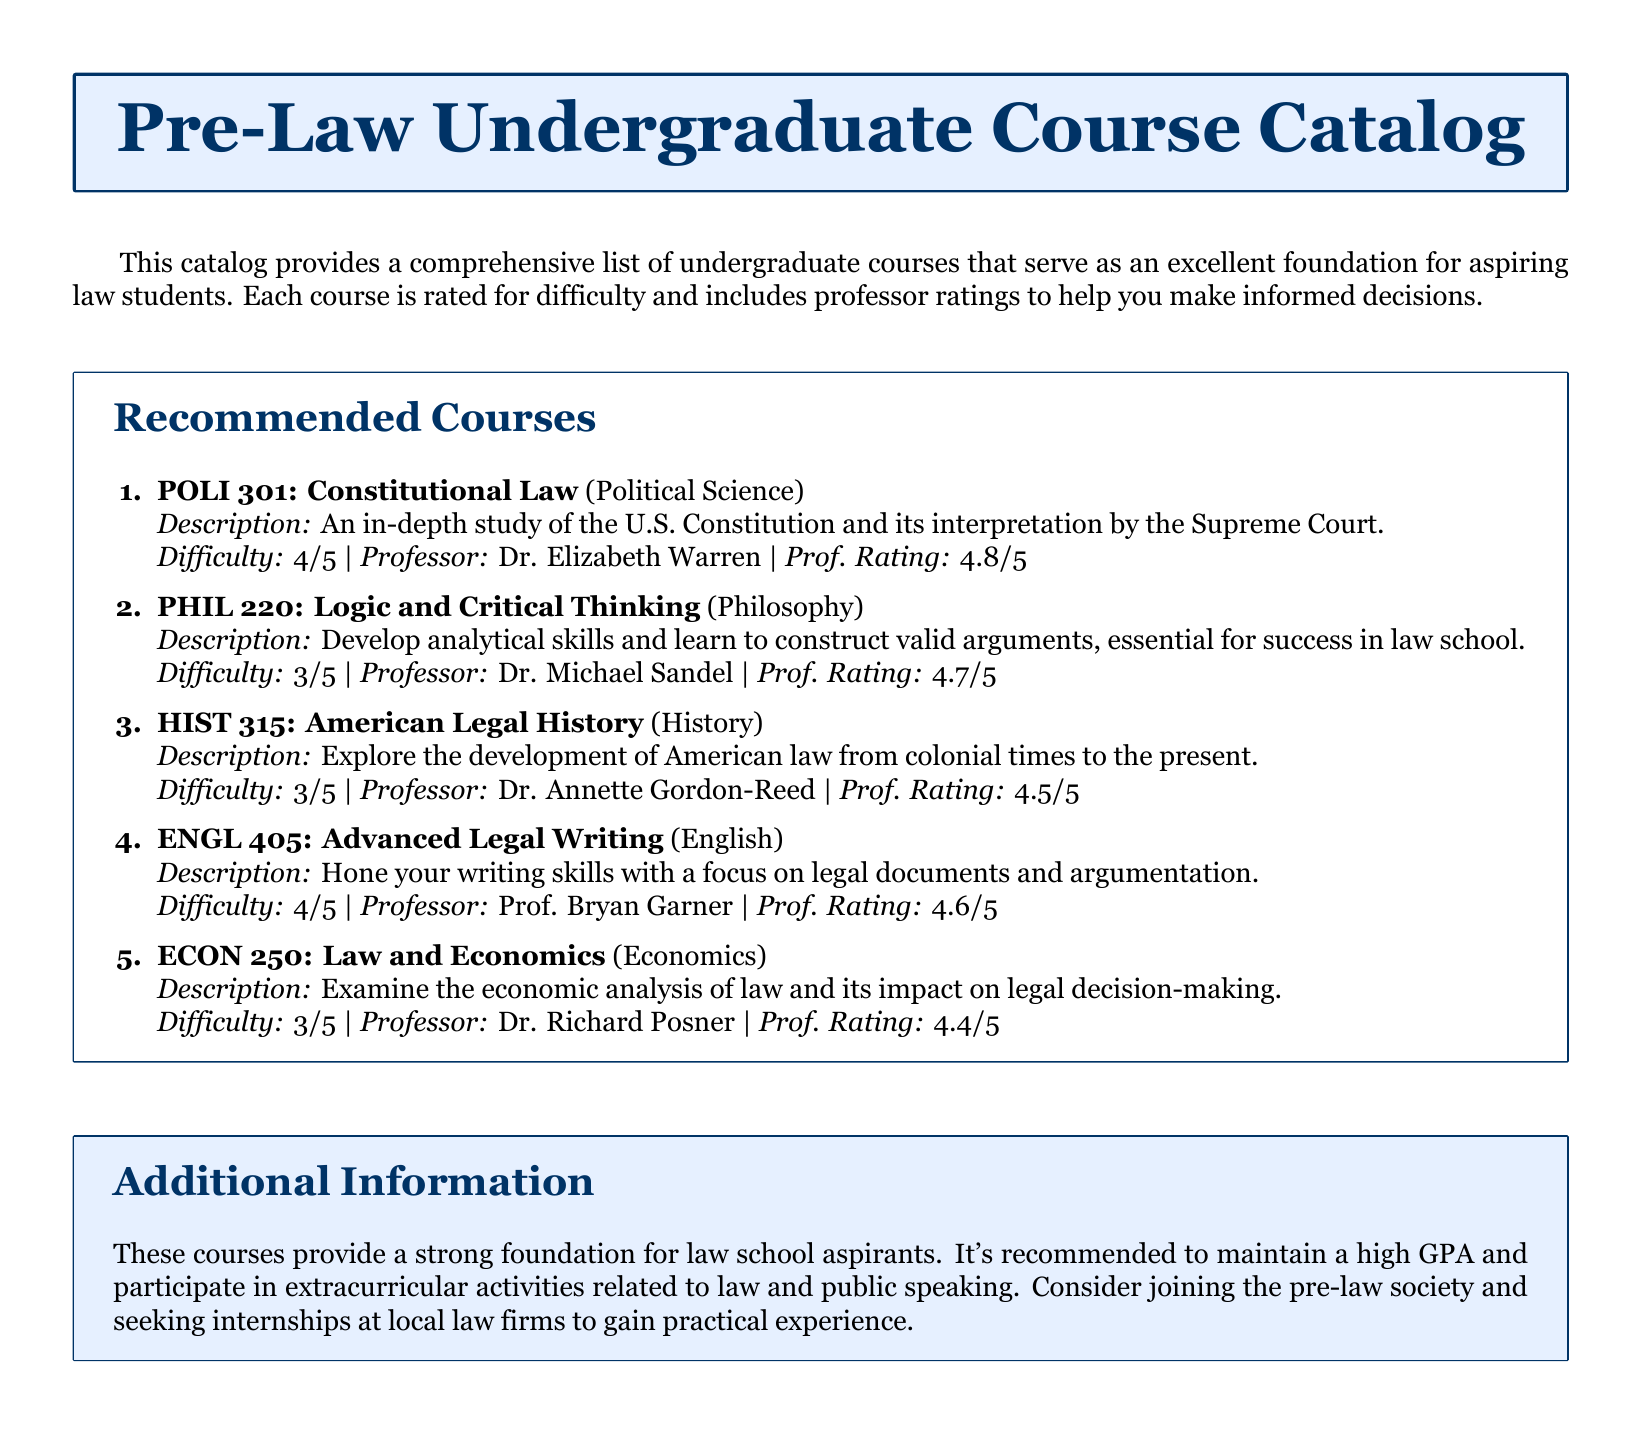What is the difficulty level of POLI 301? The difficulty level of POLI 301 is explicitly listed as 4/5 in the document.
Answer: 4/5 Who teaches PHIL 220? The professor's name for PHIL 220 is provided as Dr. Michael Sandel in the course details.
Answer: Dr. Michael Sandel What is the professor rating for HIST 315? The document states that the professor rating for HIST 315 is 4.5/5.
Answer: 4.5/5 Which course focuses on legal writing skills? The catalog highlights ENGL 405 as the course that hones writing skills with a focus on legal documents.
Answer: ENGL 405 What is the main topic of ECON 250? The document describes ECON 250 as examining the economic analysis of law and its impact on legal decision-making.
Answer: Economic analysis of law Which course is rated the highest for professor quality? The highest professor rating among the listed courses can be found in the details for POLI 301.
Answer: 4.8/5 How many courses are listed in the recommended courses section? The document lists a total of five courses in the recommended courses section.
Answer: 5 courses What additional activity is suggested for law school aspirants? The document recommends joining the pre-law society as an additional activity for those interested in law.
Answer: Pre-law society 